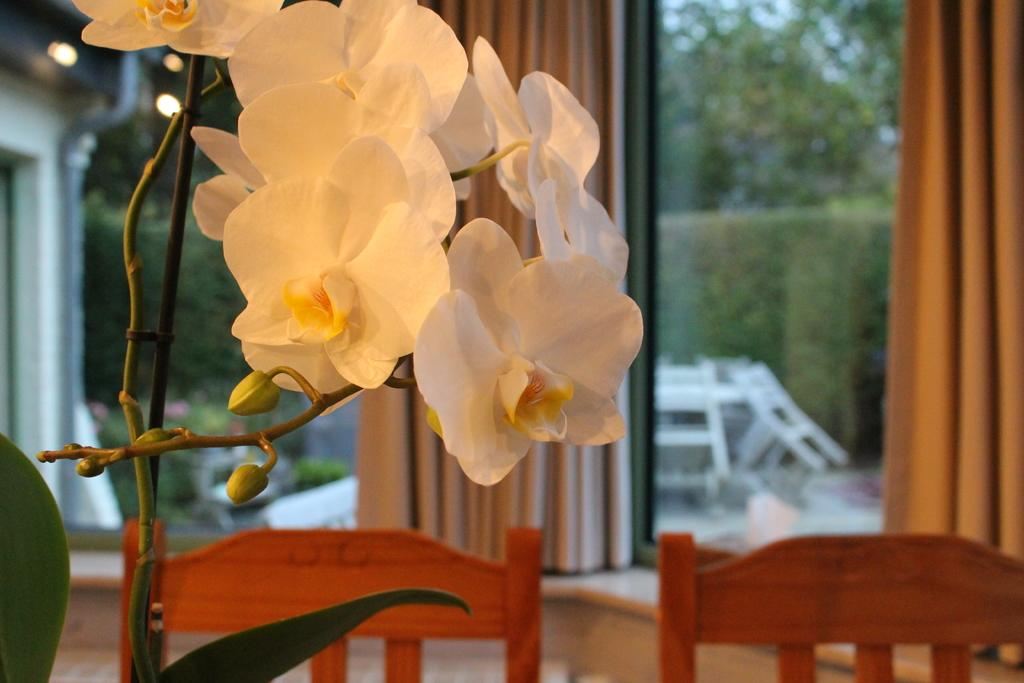What type of plant can be seen in the image? There is a plant with flowers in the image. What type of furniture is visible in the image? There are chairs visible in the image. What type of window treatment is present in the image? There are curtains in the image. What can be seen through the window in the image? Trees are visible through a window in the image. What type of toys can be seen on the table in the image? There are no toys present in the image. What type of lunch is being served in the image? There is no lunch present in the image. 